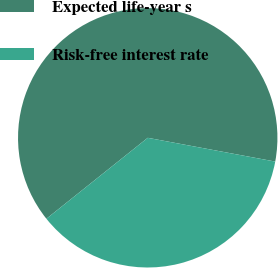Convert chart. <chart><loc_0><loc_0><loc_500><loc_500><pie_chart><fcel>Expected life-year s<fcel>Risk-free interest rate<nl><fcel>63.66%<fcel>36.34%<nl></chart> 